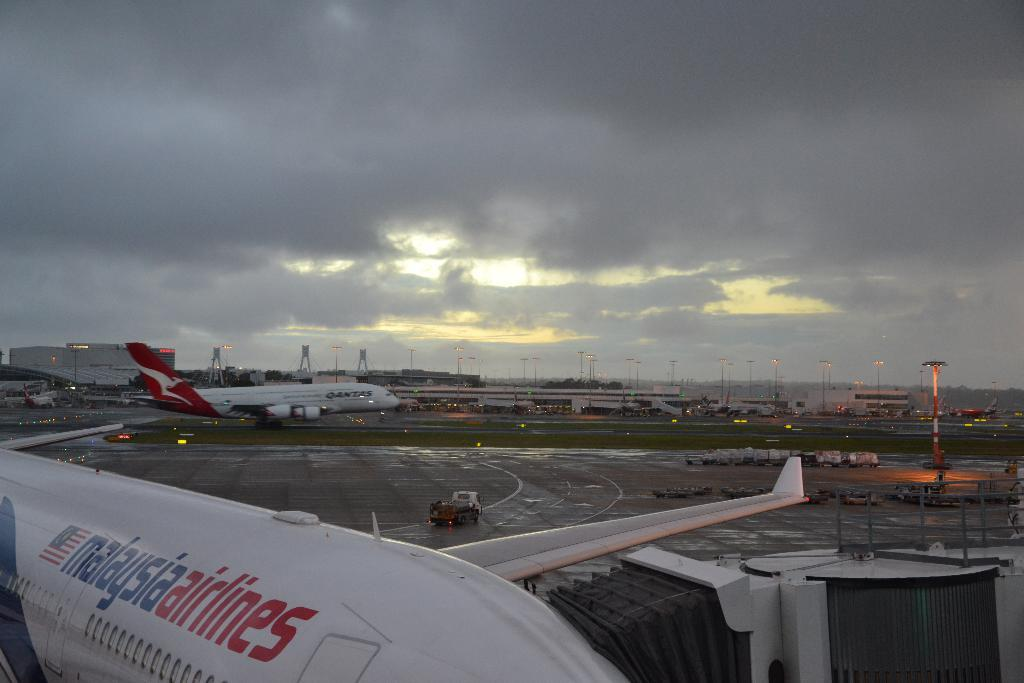Provide a one-sentence caption for the provided image. a malasia airlines plane sits with other planes at an airport. 